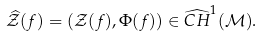<formula> <loc_0><loc_0><loc_500><loc_500>\widehat { \mathcal { Z } } ( f ) = \left ( \mathcal { Z } ( f ) , \Phi ( f ) \right ) \in \widehat { C H } ^ { 1 } ( \mathcal { M } ) .</formula> 